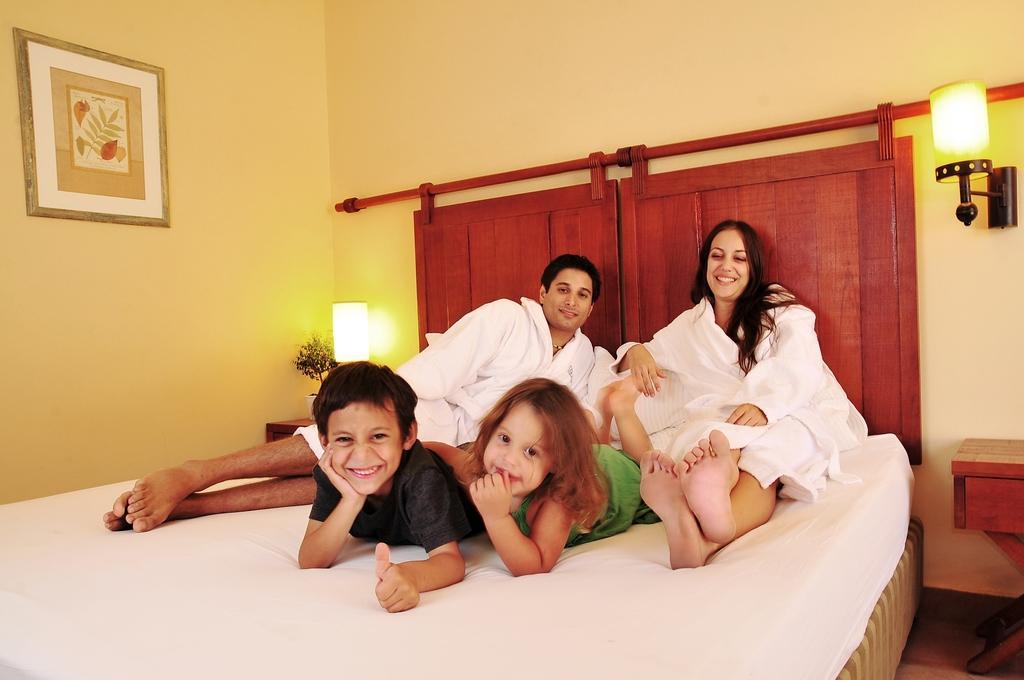Describe this image in one or two sentences. In this picture there is a family sitting on a bed women is sitting here and the man is lying on the bed and the two children is playing in between them and there is a light and there is a wall to that wall there is a photo frame. 